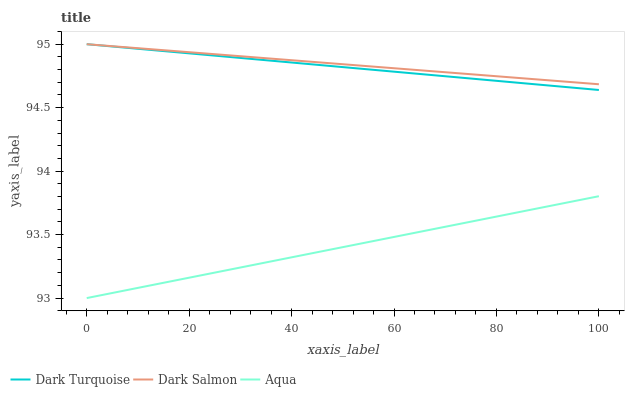Does Aqua have the minimum area under the curve?
Answer yes or no. Yes. Does Dark Salmon have the maximum area under the curve?
Answer yes or no. Yes. Does Dark Salmon have the minimum area under the curve?
Answer yes or no. No. Does Aqua have the maximum area under the curve?
Answer yes or no. No. Is Dark Salmon the smoothest?
Answer yes or no. Yes. Is Aqua the roughest?
Answer yes or no. Yes. Is Aqua the smoothest?
Answer yes or no. No. Is Dark Salmon the roughest?
Answer yes or no. No. Does Dark Salmon have the lowest value?
Answer yes or no. No. Does Aqua have the highest value?
Answer yes or no. No. Is Aqua less than Dark Turquoise?
Answer yes or no. Yes. Is Dark Salmon greater than Aqua?
Answer yes or no. Yes. Does Aqua intersect Dark Turquoise?
Answer yes or no. No. 